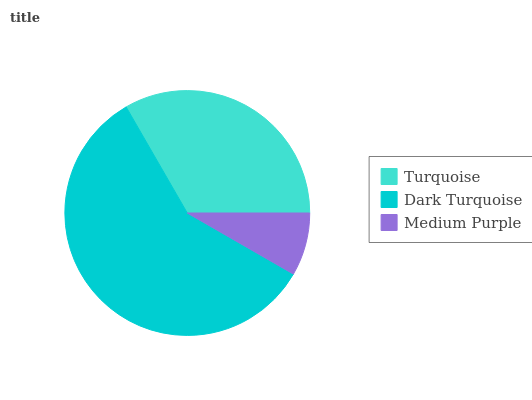Is Medium Purple the minimum?
Answer yes or no. Yes. Is Dark Turquoise the maximum?
Answer yes or no. Yes. Is Dark Turquoise the minimum?
Answer yes or no. No. Is Medium Purple the maximum?
Answer yes or no. No. Is Dark Turquoise greater than Medium Purple?
Answer yes or no. Yes. Is Medium Purple less than Dark Turquoise?
Answer yes or no. Yes. Is Medium Purple greater than Dark Turquoise?
Answer yes or no. No. Is Dark Turquoise less than Medium Purple?
Answer yes or no. No. Is Turquoise the high median?
Answer yes or no. Yes. Is Turquoise the low median?
Answer yes or no. Yes. Is Dark Turquoise the high median?
Answer yes or no. No. Is Medium Purple the low median?
Answer yes or no. No. 